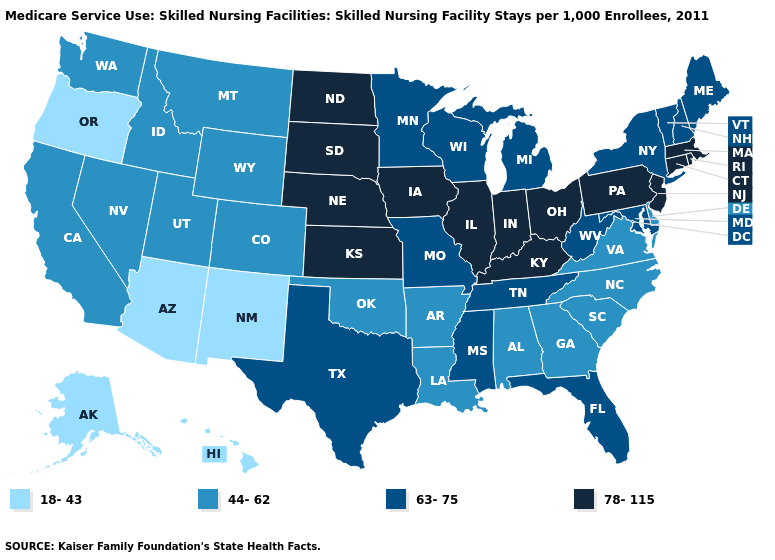What is the value of Alaska?
Quick response, please. 18-43. Does California have the lowest value in the West?
Quick response, please. No. Does Iowa have the highest value in the USA?
Be succinct. Yes. Does Arizona have the lowest value in the USA?
Give a very brief answer. Yes. Name the states that have a value in the range 63-75?
Concise answer only. Florida, Maine, Maryland, Michigan, Minnesota, Mississippi, Missouri, New Hampshire, New York, Tennessee, Texas, Vermont, West Virginia, Wisconsin. Does New York have a lower value than Oregon?
Keep it brief. No. Does Missouri have a higher value than Louisiana?
Write a very short answer. Yes. Does Colorado have a lower value than Florida?
Concise answer only. Yes. Name the states that have a value in the range 78-115?
Be succinct. Connecticut, Illinois, Indiana, Iowa, Kansas, Kentucky, Massachusetts, Nebraska, New Jersey, North Dakota, Ohio, Pennsylvania, Rhode Island, South Dakota. Which states have the highest value in the USA?
Keep it brief. Connecticut, Illinois, Indiana, Iowa, Kansas, Kentucky, Massachusetts, Nebraska, New Jersey, North Dakota, Ohio, Pennsylvania, Rhode Island, South Dakota. Does the map have missing data?
Concise answer only. No. Name the states that have a value in the range 18-43?
Quick response, please. Alaska, Arizona, Hawaii, New Mexico, Oregon. What is the value of Missouri?
Give a very brief answer. 63-75. How many symbols are there in the legend?
Concise answer only. 4. Does Indiana have the highest value in the USA?
Concise answer only. Yes. 